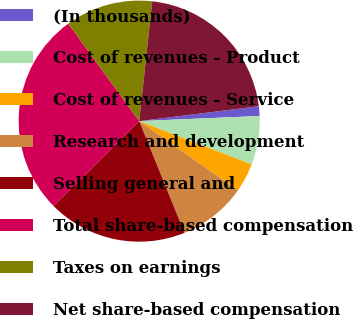<chart> <loc_0><loc_0><loc_500><loc_500><pie_chart><fcel>(In thousands)<fcel>Cost of revenues - Product<fcel>Cost of revenues - Service<fcel>Research and development<fcel>Selling general and<fcel>Total share-based compensation<fcel>Taxes on earnings<fcel>Net share-based compensation<nl><fcel>1.29%<fcel>6.52%<fcel>3.9%<fcel>9.13%<fcel>18.7%<fcel>27.41%<fcel>11.74%<fcel>21.31%<nl></chart> 